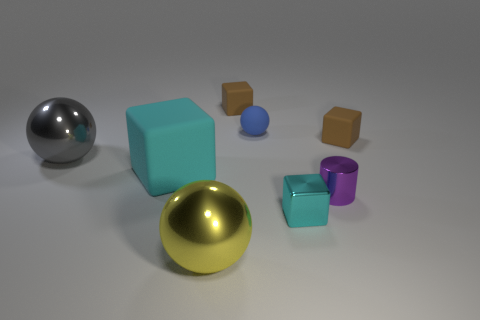Are there fewer gray objects in front of the large cyan block than large cyan blocks?
Ensure brevity in your answer.  Yes. The small cylinder that is right of the cyan block in front of the matte cube in front of the gray metal ball is what color?
Your answer should be very brief. Purple. Is there any other thing that has the same material as the gray object?
Give a very brief answer. Yes. There is a yellow metallic object that is the same shape as the small blue matte object; what size is it?
Your response must be concise. Large. Are there fewer blue balls that are right of the big cube than small cyan objects that are behind the big gray metal sphere?
Give a very brief answer. No. The thing that is to the left of the shiny block and in front of the large cyan thing has what shape?
Your response must be concise. Sphere. What is the size of the cyan block that is the same material as the blue sphere?
Make the answer very short. Large. Do the small matte ball and the small metallic cube in front of the cylinder have the same color?
Provide a short and direct response. No. There is a tiny object that is both left of the shiny cylinder and in front of the big gray object; what material is it?
Give a very brief answer. Metal. There is a thing that is the same color as the large rubber block; what size is it?
Provide a succinct answer. Small. 